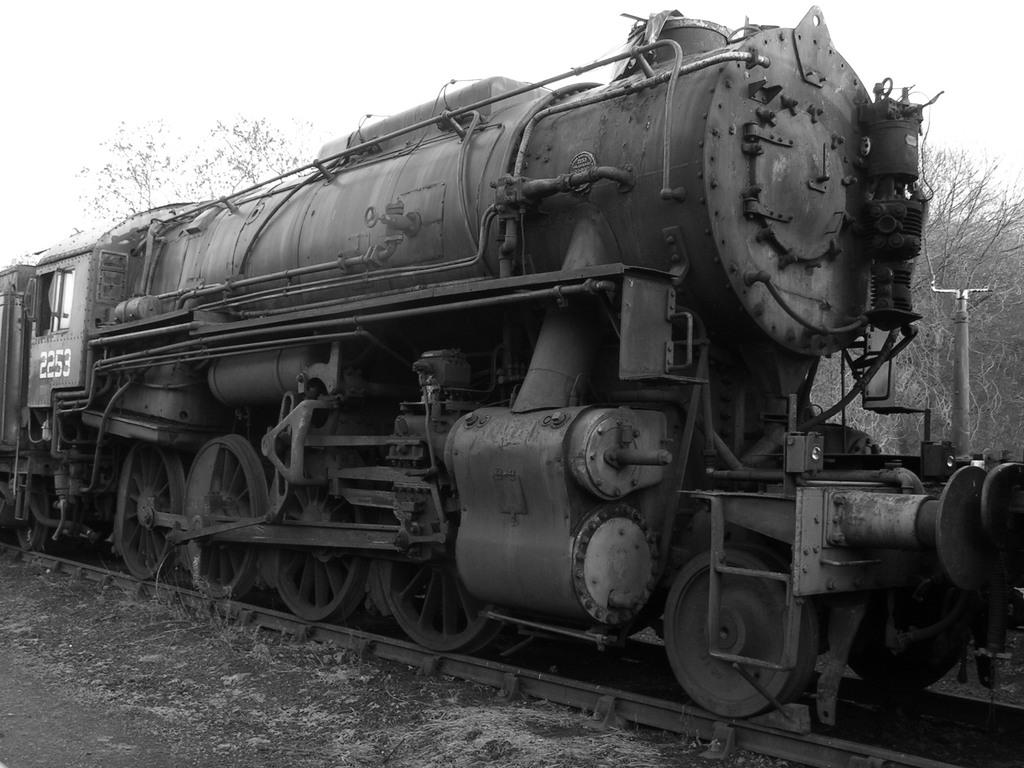What is the main subject of the image? The main subject of the image is a train. Where is the train located in the image? The train is on a track. What can be seen in the background of the image? There are trees and the sky visible in the background of the image. What type of memory is stored in the crate in the image? There is no crate present in the image, so it is not possible to determine what type of memory might be stored in it. 